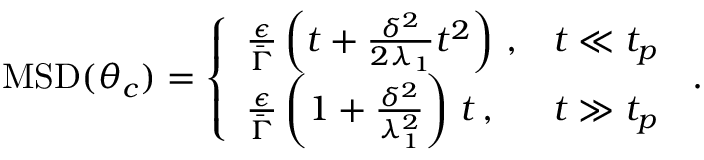<formula> <loc_0><loc_0><loc_500><loc_500>\begin{array} { r } { M S D ( \theta _ { c } ) = \left \{ \begin{array} { l l } { \frac { \epsilon } { \bar { \Gamma } } \left ( t + \frac { \delta ^ { 2 } } { 2 \lambda _ { 1 } } t ^ { 2 } \right ) \, , } & { t \ll t _ { p } } \\ { \frac { \epsilon } { \bar { \Gamma } } \left ( 1 + \frac { \delta ^ { 2 } } { \lambda _ { 1 } ^ { 2 } } \right ) \, t \, , } & { t \gg t _ { p } \, } \end{array} . } \end{array}</formula> 